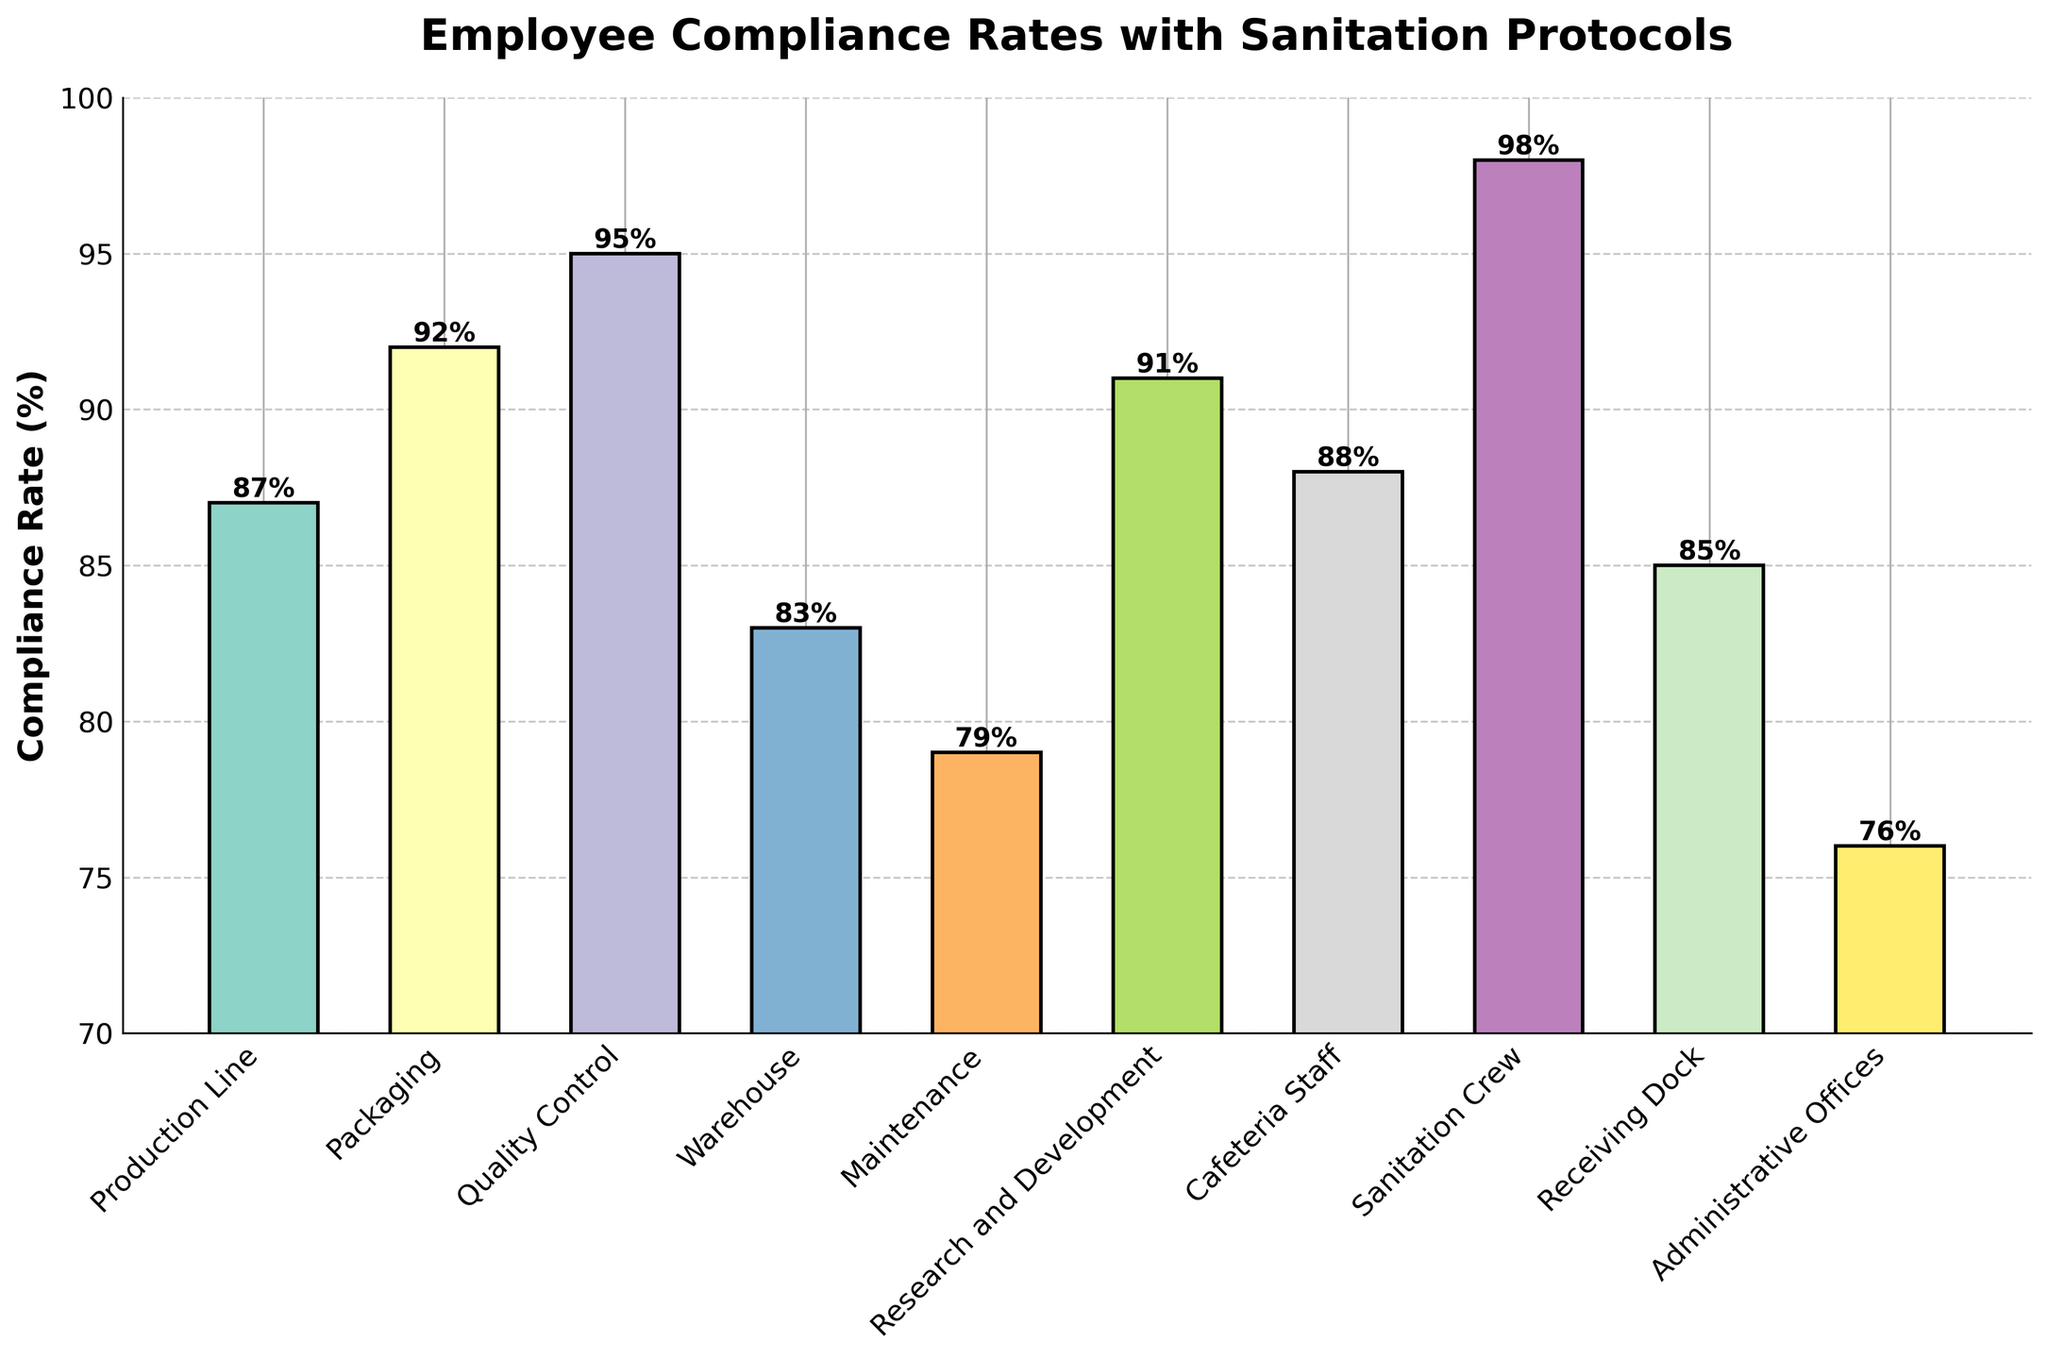Which department has the highest compliance rate? The department with the highest compliance rate can be identified by looking for the tallest bar in the chart.
Answer: Sanitation Crew Which department has the lowest compliance rate? The department with the lowest compliance rate can be found by looking for the shortest bar in the chart.
Answer: Administrative Offices What is the compliance rate difference between the Production Line and the Packaging department? Subtract the compliance rate of the Production Line (87%) from the Packaging department (92%).
Answer: 5% Is the compliance rate of the Quality Control department higher than that of the Research and Development department? Compare the compliance rate of the Quality Control department (95%) with the Research and Development department (91%).
Answer: Yes Which departments have a compliance rate above 90%? Identify the bars that exceed the 90% mark on the vertical axis.
Answer: Packaging, Quality Control, Research and Development, Sanitation Crew How many departments have a compliance rate below 80%? Count the number of bars that fall below the 80% mark on the vertical axis.
Answer: Two What is the difference in compliance rates between the Warehouse and the Maintenance departments? Subtract the compliance rate of the Maintenance department (79%) from the compliance rate of the Warehouse (83%).
Answer: 4% Is there any department with a compliance rate exactly at 85%? If yes, which one? Look for any bar that reaches exactly the 85% mark on the vertical axis.
Answer: Receiving Dock What is the average compliance rate of all departments? Sum the compliance rates of all departments and divide by the number of departments: (87 + 92 + 95 + 83 + 79 + 91 + 88 + 98 + 85 + 76)/10.
Answer: 87.4% Do the Production Line and the Cafeteria Staff have similar compliance rates? Compare the compliance rates of the Production Line (87%) and the Cafeteria Staff (88%).
Answer: Yes 